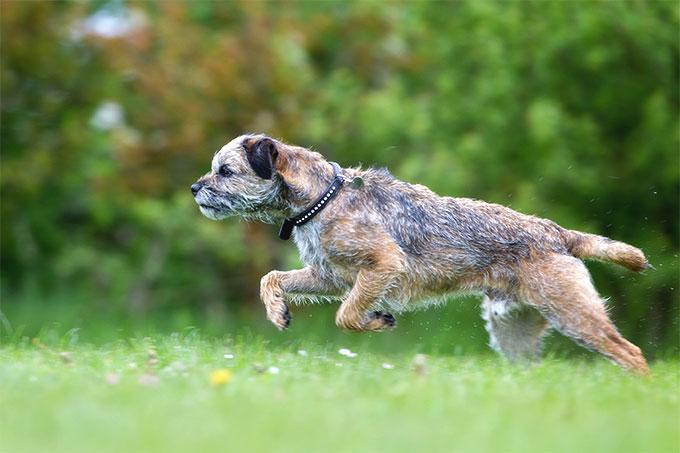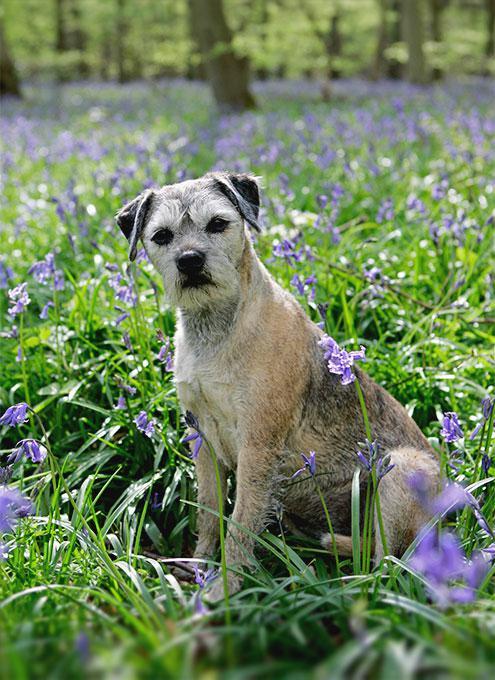The first image is the image on the left, the second image is the image on the right. For the images shown, is this caption "A dog stands still in profile facing left with tail extended out." true? Answer yes or no. No. The first image is the image on the left, the second image is the image on the right. For the images displayed, is the sentence "The left image contains a dog facing towards the left." factually correct? Answer yes or no. Yes. 